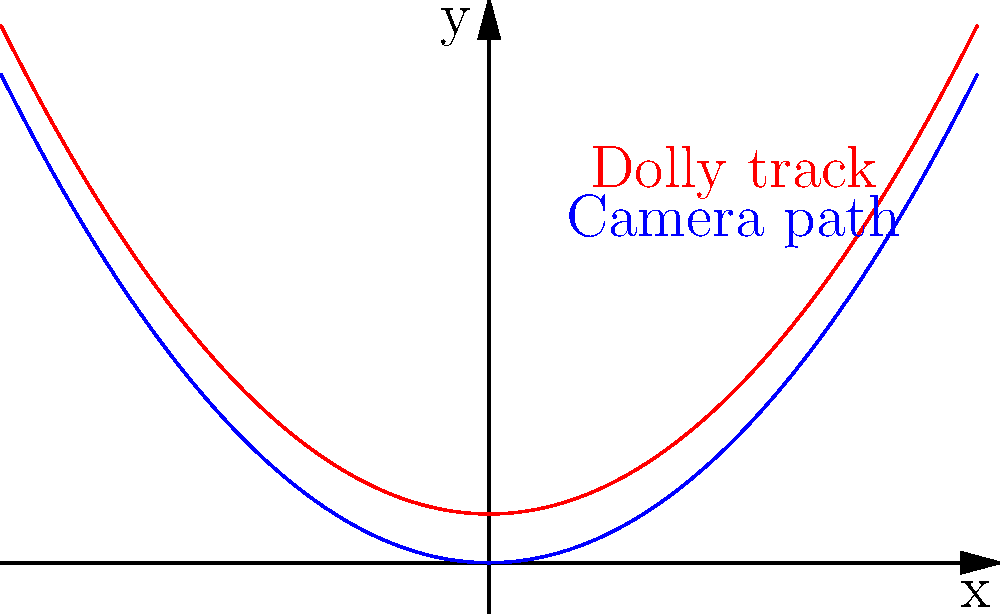As a filmmaker planning a complex dolly shot, you need to determine the curve of the dolly track for smooth camera movement. The camera path is given by the function $f(x) = 0.1x^2$, and you want the dolly track to be parallel to this path, maintaining a constant vertical distance of 1 unit. Find the equation of the dolly track curve $g(x)$. To solve this problem, we'll follow these steps:

1) The camera path is given by the function $f(x) = 0.1x^2$.

2) We want the dolly track to be parallel to this path, maintaining a constant vertical distance of 1 unit.

3) To achieve this, we need to add 1 to the function $f(x)$ for all values of $x$. This will shift the entire curve up by 1 unit.

4) Therefore, the equation of the dolly track curve $g(x)$ will be:

   $g(x) = f(x) + 1$

5) Substituting the given function for $f(x)$:

   $g(x) = 0.1x^2 + 1$

This equation represents a parabola that is exactly 1 unit above the camera path at every point, ensuring smooth and parallel movement.
Answer: $g(x) = 0.1x^2 + 1$ 